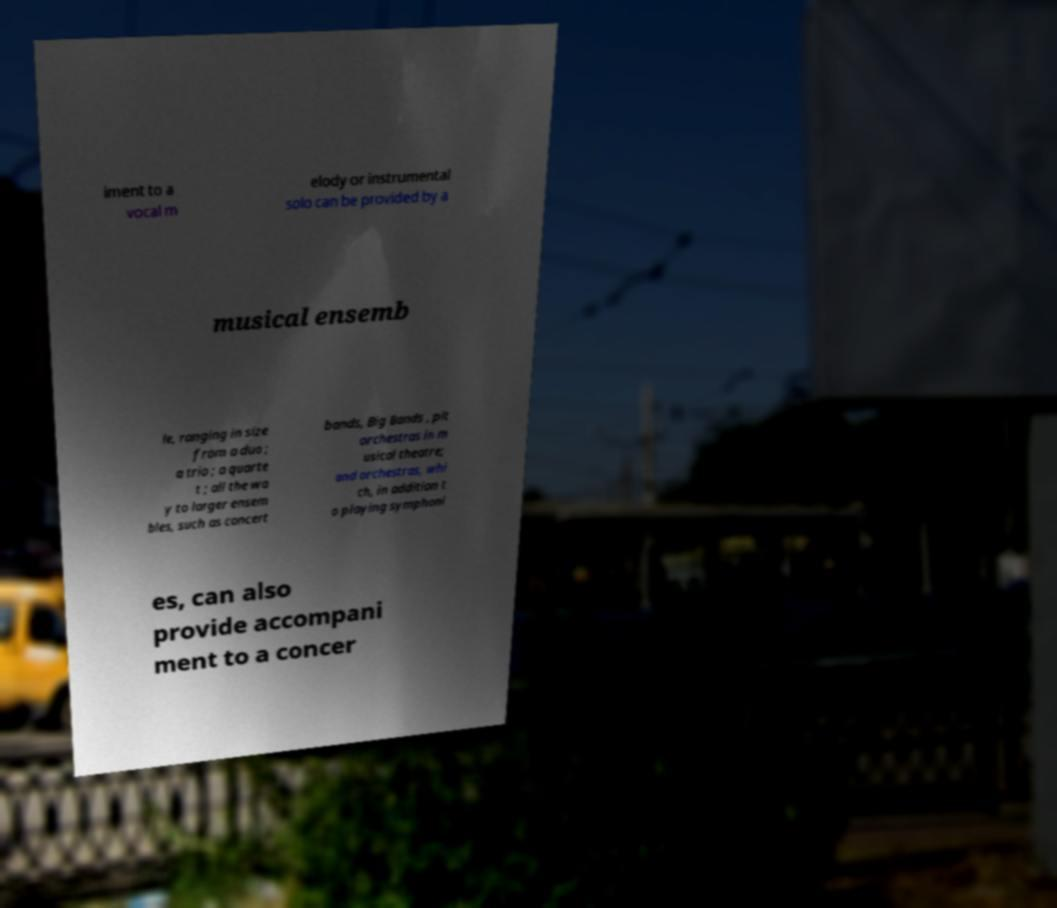Please identify and transcribe the text found in this image. iment to a vocal m elody or instrumental solo can be provided by a musical ensemb le, ranging in size from a duo ; a trio ; a quarte t ; all the wa y to larger ensem bles, such as concert bands, Big Bands , pit orchestras in m usical theatre; and orchestras, whi ch, in addition t o playing symphoni es, can also provide accompani ment to a concer 